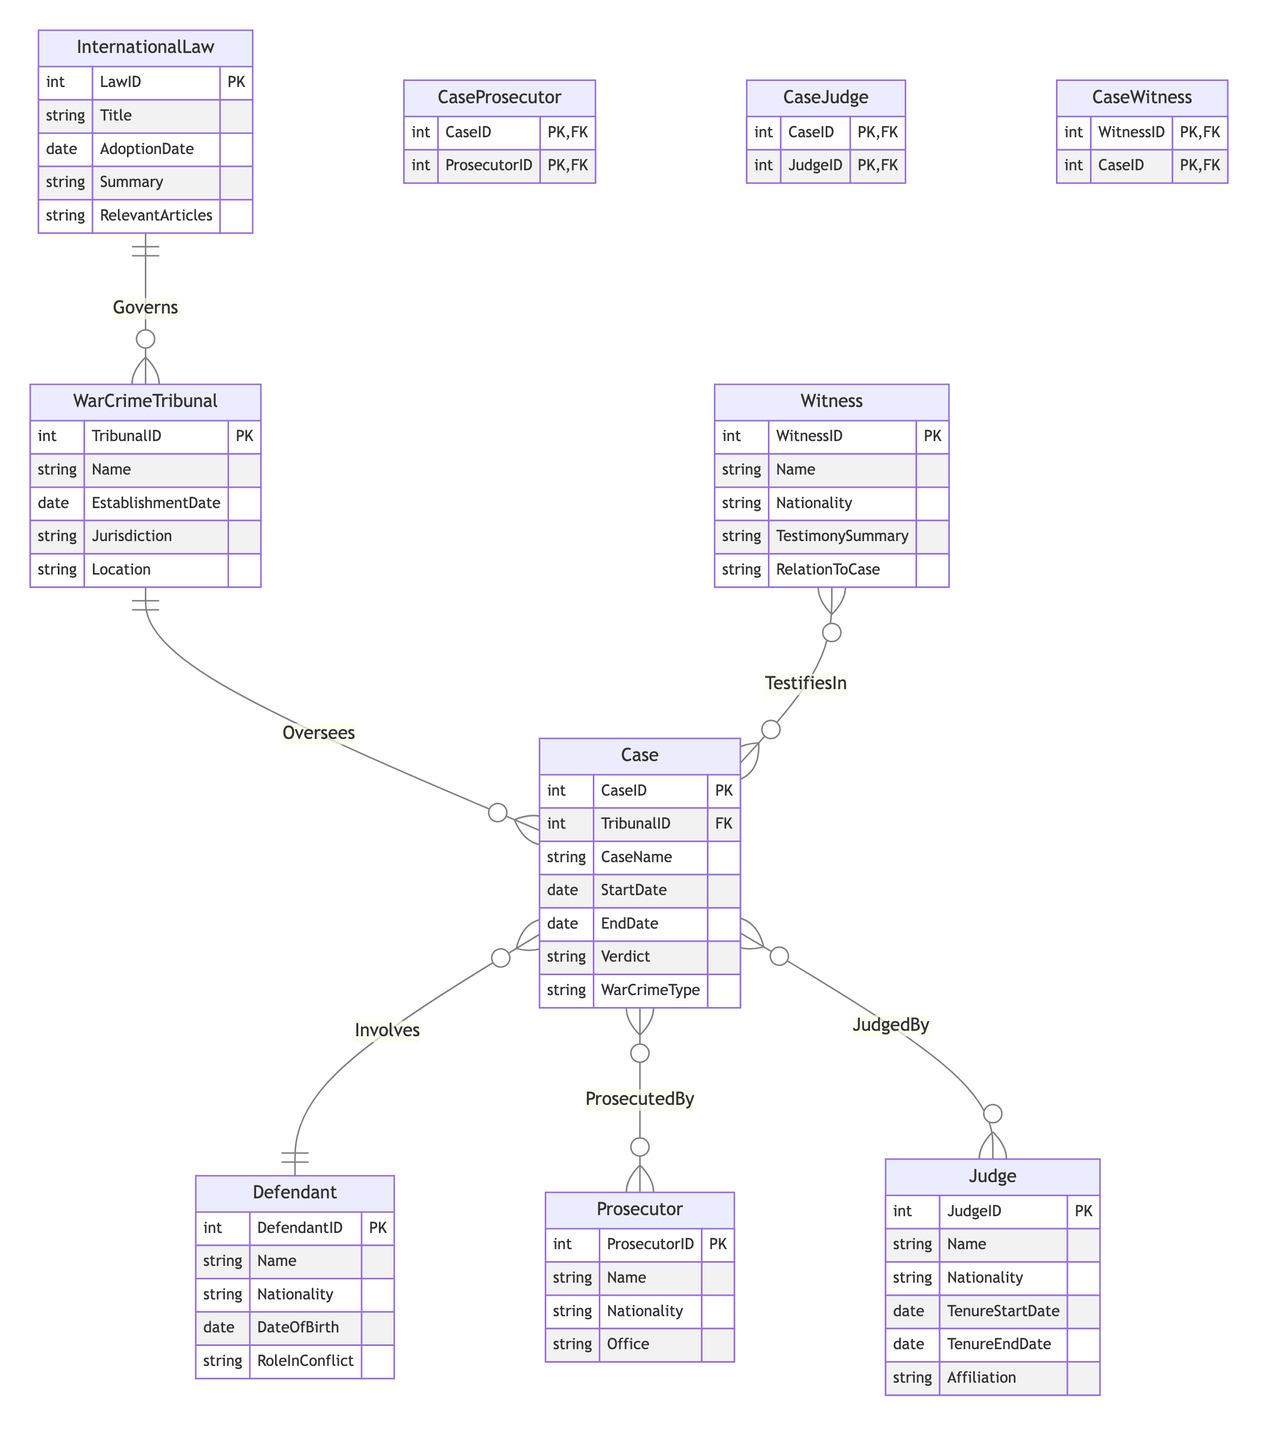What is the primary key of the WarCrimeTribunal entity? The primary key of the WarCrimeTribunal entity is TribunalID, which uniquely identifies each tribunal.
Answer: TribunalID How many entities are in this diagram? Counting the entities listed, there are seven entities: WarCrimeTribunal, Case, Defendant, Prosecutor, Judge, InternationalLaw, and Witness.
Answer: 7 What type of relationship exists between Case and Defendant? The relationship between Case and Defendant is "Involves," indicating that a case can have multiple defendants.
Answer: Involves What is the cardinality of the relationship between WarCrimeTribunal and Case? The cardinality between WarCrimeTribunal and Case is "1:M," meaning one tribunal can oversee many cases.
Answer: 1:M Which entity governs the WarCrimeTribunal? The entity that governs the WarCrimeTribunal is InternationalLaw, which defines the legal framework for the tribunal's operations.
Answer: InternationalLaw What is the name of the intersection entity that connects Prosecutor and Case? The intersection entity that connects Prosecutor and Case is CaseProsecutor, which identifies the relationship between cases and the prosecutors handling them.
Answer: CaseProsecutor How many judges can be involved in a single case? The relationship "JudgedBy" indicates a many-to-many relationship, meaning one case can have multiple judges, and a judge can work on multiple cases.
Answer: Multiple What identifies a witness's relationship to a case? A witness's relationship to a case is identified through the entity CaseWitness, which captures their involvement in particular cases.
Answer: CaseWitness What is the primary key of the Case entity? The primary key of the Case entity is CaseID, which uniquely identifies each war crime case.
Answer: CaseID 